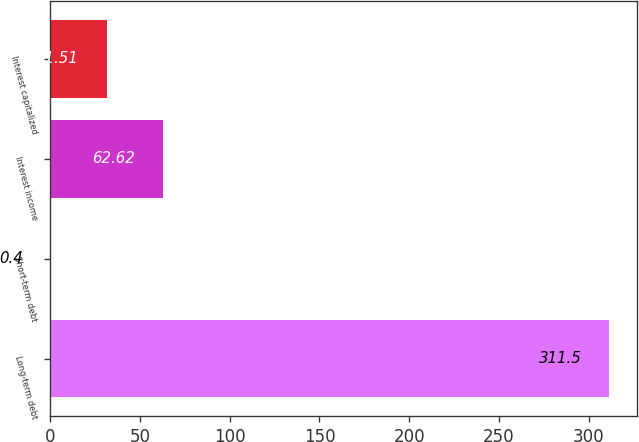Convert chart. <chart><loc_0><loc_0><loc_500><loc_500><bar_chart><fcel>Long-term debt<fcel>Short-term debt<fcel>Interest income<fcel>Interest capitalized<nl><fcel>311.5<fcel>0.4<fcel>62.62<fcel>31.51<nl></chart> 